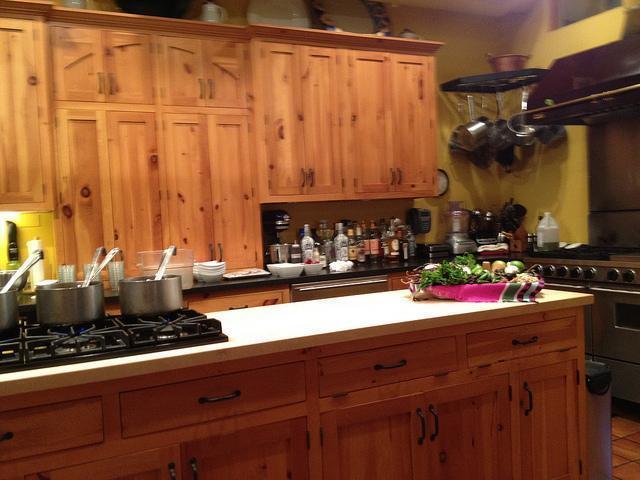What is the object called which is supporting the stove?
Indicate the correct response by choosing from the four available options to answer the question.
Options: Cabinet, prep table, bar top, island. Island. 